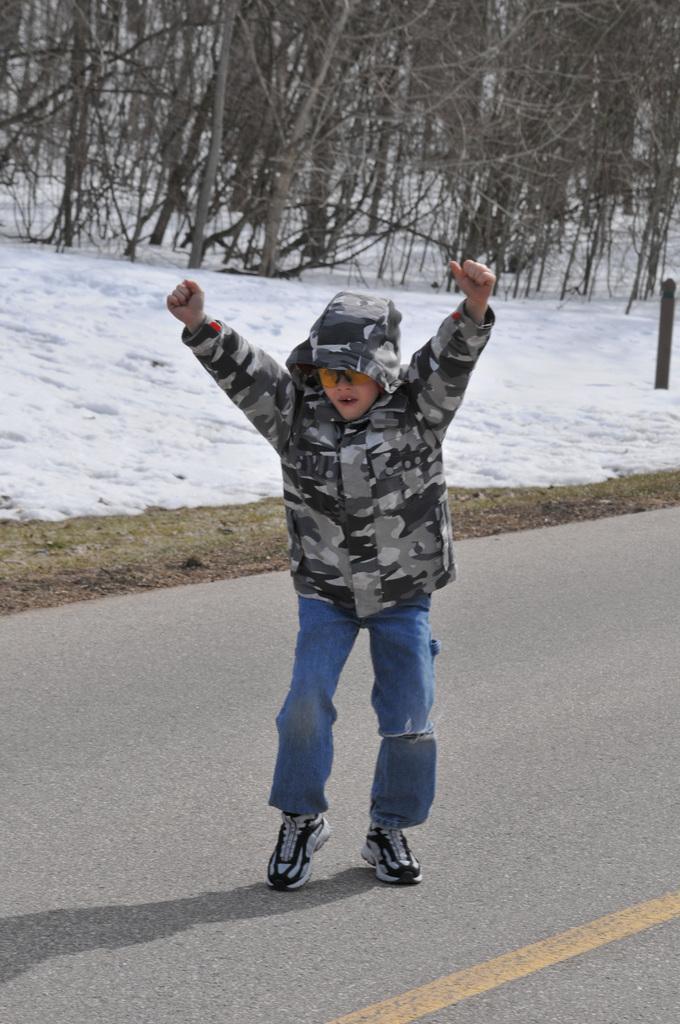Please provide a concise description of this image. In this image, we can see a kid on the road. There is a snow in the middle of the image. There are trees at the top of the image. 